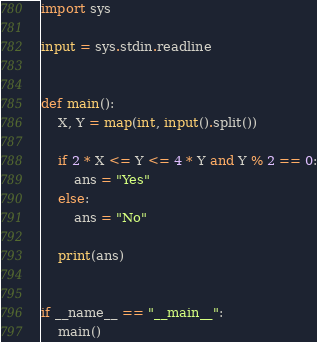Convert code to text. <code><loc_0><loc_0><loc_500><loc_500><_Python_>import sys

input = sys.stdin.readline


def main():
    X, Y = map(int, input().split())

    if 2 * X <= Y <= 4 * Y and Y % 2 == 0:
        ans = "Yes"
    else:
        ans = "No"

    print(ans)


if __name__ == "__main__":
    main()
</code> 